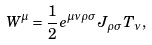Convert formula to latex. <formula><loc_0><loc_0><loc_500><loc_500>W ^ { \mu } = \frac { 1 } { 2 } e ^ { \mu \nu \rho \sigma } J _ { \rho \sigma } T _ { \nu } ,</formula> 